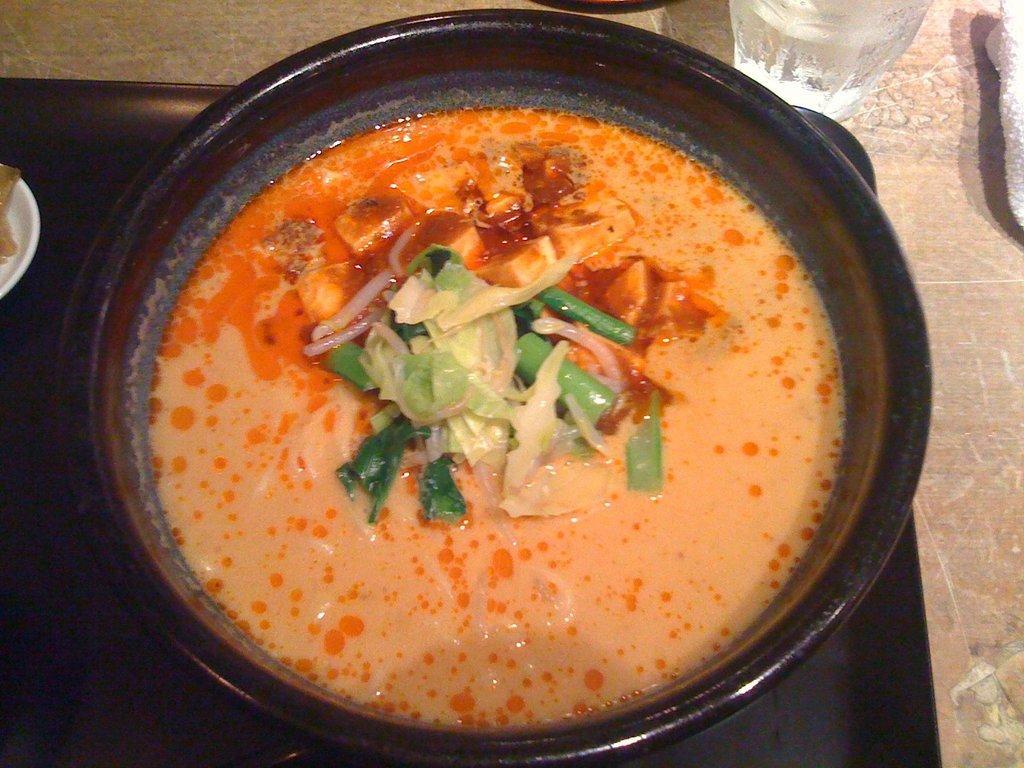Can you describe this image briefly? In this image we can see a table. On the table there are serving bowl with food in it, glass tumbler, napkin and a tray. 